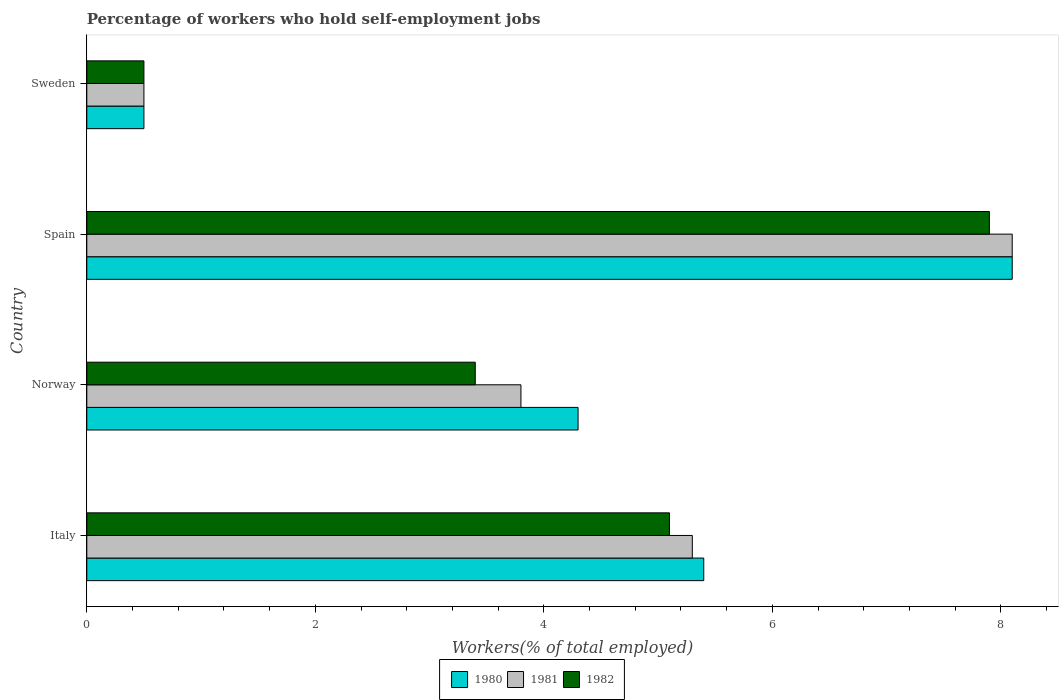How many groups of bars are there?
Your answer should be compact. 4. Are the number of bars per tick equal to the number of legend labels?
Your response must be concise. Yes. How many bars are there on the 2nd tick from the bottom?
Your answer should be compact. 3. What is the label of the 2nd group of bars from the top?
Offer a very short reply. Spain. In how many cases, is the number of bars for a given country not equal to the number of legend labels?
Make the answer very short. 0. What is the percentage of self-employed workers in 1980 in Norway?
Ensure brevity in your answer.  4.3. Across all countries, what is the maximum percentage of self-employed workers in 1980?
Keep it short and to the point. 8.1. Across all countries, what is the minimum percentage of self-employed workers in 1981?
Keep it short and to the point. 0.5. What is the total percentage of self-employed workers in 1982 in the graph?
Provide a short and direct response. 16.9. What is the difference between the percentage of self-employed workers in 1980 in Italy and that in Spain?
Your response must be concise. -2.7. What is the difference between the percentage of self-employed workers in 1980 in Spain and the percentage of self-employed workers in 1982 in Sweden?
Ensure brevity in your answer.  7.6. What is the average percentage of self-employed workers in 1982 per country?
Your answer should be compact. 4.23. What is the difference between the percentage of self-employed workers in 1982 and percentage of self-employed workers in 1980 in Italy?
Provide a short and direct response. -0.3. In how many countries, is the percentage of self-employed workers in 1982 greater than 3.6 %?
Ensure brevity in your answer.  2. What is the ratio of the percentage of self-employed workers in 1980 in Norway to that in Sweden?
Provide a succinct answer. 8.6. Is the percentage of self-employed workers in 1982 in Italy less than that in Norway?
Make the answer very short. No. Is the difference between the percentage of self-employed workers in 1982 in Norway and Spain greater than the difference between the percentage of self-employed workers in 1980 in Norway and Spain?
Ensure brevity in your answer.  No. What is the difference between the highest and the second highest percentage of self-employed workers in 1982?
Your answer should be compact. 2.8. What is the difference between the highest and the lowest percentage of self-employed workers in 1981?
Ensure brevity in your answer.  7.6. Is the sum of the percentage of self-employed workers in 1982 in Italy and Spain greater than the maximum percentage of self-employed workers in 1980 across all countries?
Provide a short and direct response. Yes. Is it the case that in every country, the sum of the percentage of self-employed workers in 1981 and percentage of self-employed workers in 1982 is greater than the percentage of self-employed workers in 1980?
Provide a succinct answer. Yes. How many bars are there?
Provide a short and direct response. 12. How many countries are there in the graph?
Your answer should be compact. 4. Does the graph contain grids?
Keep it short and to the point. No. Where does the legend appear in the graph?
Your answer should be compact. Bottom center. What is the title of the graph?
Your answer should be very brief. Percentage of workers who hold self-employment jobs. Does "1978" appear as one of the legend labels in the graph?
Offer a very short reply. No. What is the label or title of the X-axis?
Your answer should be very brief. Workers(% of total employed). What is the Workers(% of total employed) of 1980 in Italy?
Keep it short and to the point. 5.4. What is the Workers(% of total employed) of 1981 in Italy?
Provide a succinct answer. 5.3. What is the Workers(% of total employed) of 1982 in Italy?
Offer a terse response. 5.1. What is the Workers(% of total employed) in 1980 in Norway?
Give a very brief answer. 4.3. What is the Workers(% of total employed) in 1981 in Norway?
Give a very brief answer. 3.8. What is the Workers(% of total employed) in 1982 in Norway?
Provide a succinct answer. 3.4. What is the Workers(% of total employed) in 1980 in Spain?
Your response must be concise. 8.1. What is the Workers(% of total employed) of 1981 in Spain?
Make the answer very short. 8.1. What is the Workers(% of total employed) of 1982 in Spain?
Ensure brevity in your answer.  7.9. What is the Workers(% of total employed) of 1980 in Sweden?
Provide a short and direct response. 0.5. What is the Workers(% of total employed) of 1981 in Sweden?
Offer a terse response. 0.5. Across all countries, what is the maximum Workers(% of total employed) of 1980?
Offer a terse response. 8.1. Across all countries, what is the maximum Workers(% of total employed) in 1981?
Your answer should be very brief. 8.1. Across all countries, what is the maximum Workers(% of total employed) of 1982?
Make the answer very short. 7.9. Across all countries, what is the minimum Workers(% of total employed) in 1980?
Your answer should be compact. 0.5. What is the total Workers(% of total employed) of 1980 in the graph?
Provide a succinct answer. 18.3. What is the total Workers(% of total employed) in 1981 in the graph?
Offer a very short reply. 17.7. What is the total Workers(% of total employed) in 1982 in the graph?
Provide a short and direct response. 16.9. What is the difference between the Workers(% of total employed) in 1981 in Italy and that in Spain?
Your answer should be very brief. -2.8. What is the difference between the Workers(% of total employed) of 1980 in Italy and that in Sweden?
Provide a short and direct response. 4.9. What is the difference between the Workers(% of total employed) in 1981 in Norway and that in Spain?
Give a very brief answer. -4.3. What is the difference between the Workers(% of total employed) in 1980 in Norway and that in Sweden?
Your answer should be compact. 3.8. What is the difference between the Workers(% of total employed) in 1981 in Spain and that in Sweden?
Ensure brevity in your answer.  7.6. What is the difference between the Workers(% of total employed) in 1980 in Italy and the Workers(% of total employed) in 1981 in Norway?
Your answer should be compact. 1.6. What is the difference between the Workers(% of total employed) in 1981 in Italy and the Workers(% of total employed) in 1982 in Norway?
Provide a succinct answer. 1.9. What is the difference between the Workers(% of total employed) of 1980 in Italy and the Workers(% of total employed) of 1981 in Spain?
Your answer should be very brief. -2.7. What is the difference between the Workers(% of total employed) of 1980 in Italy and the Workers(% of total employed) of 1982 in Spain?
Provide a short and direct response. -2.5. What is the difference between the Workers(% of total employed) in 1981 in Italy and the Workers(% of total employed) in 1982 in Spain?
Provide a succinct answer. -2.6. What is the difference between the Workers(% of total employed) of 1980 in Italy and the Workers(% of total employed) of 1981 in Sweden?
Provide a succinct answer. 4.9. What is the difference between the Workers(% of total employed) in 1980 in Italy and the Workers(% of total employed) in 1982 in Sweden?
Make the answer very short. 4.9. What is the difference between the Workers(% of total employed) of 1980 in Norway and the Workers(% of total employed) of 1981 in Spain?
Offer a very short reply. -3.8. What is the difference between the Workers(% of total employed) in 1980 in Norway and the Workers(% of total employed) in 1982 in Sweden?
Keep it short and to the point. 3.8. What is the difference between the Workers(% of total employed) in 1980 in Spain and the Workers(% of total employed) in 1981 in Sweden?
Ensure brevity in your answer.  7.6. What is the difference between the Workers(% of total employed) of 1981 in Spain and the Workers(% of total employed) of 1982 in Sweden?
Your answer should be very brief. 7.6. What is the average Workers(% of total employed) in 1980 per country?
Your response must be concise. 4.58. What is the average Workers(% of total employed) of 1981 per country?
Provide a short and direct response. 4.42. What is the average Workers(% of total employed) of 1982 per country?
Give a very brief answer. 4.22. What is the difference between the Workers(% of total employed) in 1980 and Workers(% of total employed) in 1981 in Italy?
Ensure brevity in your answer.  0.1. What is the difference between the Workers(% of total employed) in 1980 and Workers(% of total employed) in 1981 in Norway?
Provide a succinct answer. 0.5. What is the difference between the Workers(% of total employed) in 1980 and Workers(% of total employed) in 1982 in Spain?
Provide a short and direct response. 0.2. What is the difference between the Workers(% of total employed) in 1981 and Workers(% of total employed) in 1982 in Spain?
Your answer should be very brief. 0.2. What is the difference between the Workers(% of total employed) of 1980 and Workers(% of total employed) of 1981 in Sweden?
Your answer should be compact. 0. What is the difference between the Workers(% of total employed) of 1980 and Workers(% of total employed) of 1982 in Sweden?
Ensure brevity in your answer.  0. What is the ratio of the Workers(% of total employed) in 1980 in Italy to that in Norway?
Your answer should be compact. 1.26. What is the ratio of the Workers(% of total employed) in 1981 in Italy to that in Norway?
Offer a very short reply. 1.39. What is the ratio of the Workers(% of total employed) of 1980 in Italy to that in Spain?
Your answer should be compact. 0.67. What is the ratio of the Workers(% of total employed) in 1981 in Italy to that in Spain?
Keep it short and to the point. 0.65. What is the ratio of the Workers(% of total employed) of 1982 in Italy to that in Spain?
Offer a terse response. 0.65. What is the ratio of the Workers(% of total employed) in 1981 in Italy to that in Sweden?
Ensure brevity in your answer.  10.6. What is the ratio of the Workers(% of total employed) of 1980 in Norway to that in Spain?
Make the answer very short. 0.53. What is the ratio of the Workers(% of total employed) in 1981 in Norway to that in Spain?
Give a very brief answer. 0.47. What is the ratio of the Workers(% of total employed) in 1982 in Norway to that in Spain?
Ensure brevity in your answer.  0.43. What is the ratio of the Workers(% of total employed) in 1981 in Norway to that in Sweden?
Offer a terse response. 7.6. What is the ratio of the Workers(% of total employed) in 1982 in Norway to that in Sweden?
Your answer should be very brief. 6.8. What is the difference between the highest and the second highest Workers(% of total employed) in 1980?
Your answer should be very brief. 2.7. What is the difference between the highest and the second highest Workers(% of total employed) in 1982?
Make the answer very short. 2.8. What is the difference between the highest and the lowest Workers(% of total employed) of 1980?
Your response must be concise. 7.6. What is the difference between the highest and the lowest Workers(% of total employed) of 1981?
Offer a very short reply. 7.6. What is the difference between the highest and the lowest Workers(% of total employed) in 1982?
Provide a short and direct response. 7.4. 